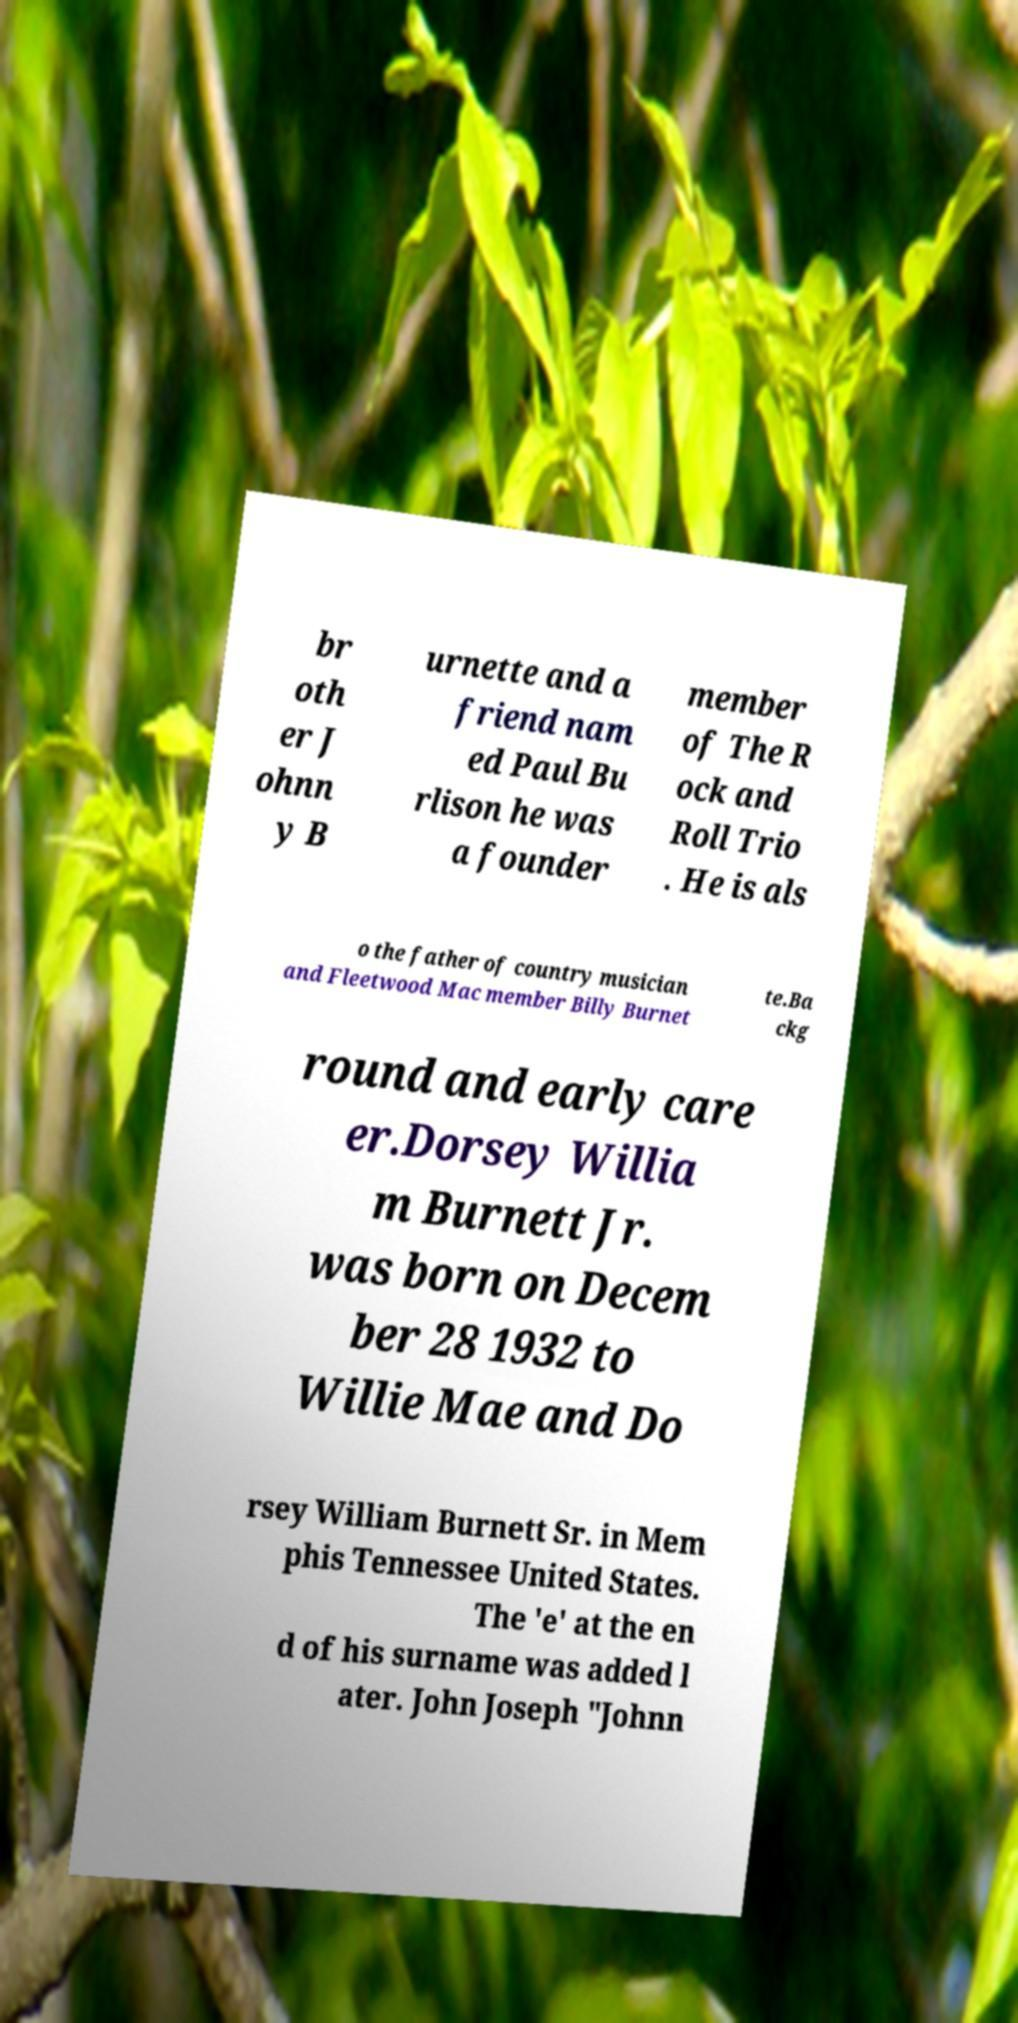There's text embedded in this image that I need extracted. Can you transcribe it verbatim? br oth er J ohnn y B urnette and a friend nam ed Paul Bu rlison he was a founder member of The R ock and Roll Trio . He is als o the father of country musician and Fleetwood Mac member Billy Burnet te.Ba ckg round and early care er.Dorsey Willia m Burnett Jr. was born on Decem ber 28 1932 to Willie Mae and Do rsey William Burnett Sr. in Mem phis Tennessee United States. The 'e' at the en d of his surname was added l ater. John Joseph "Johnn 